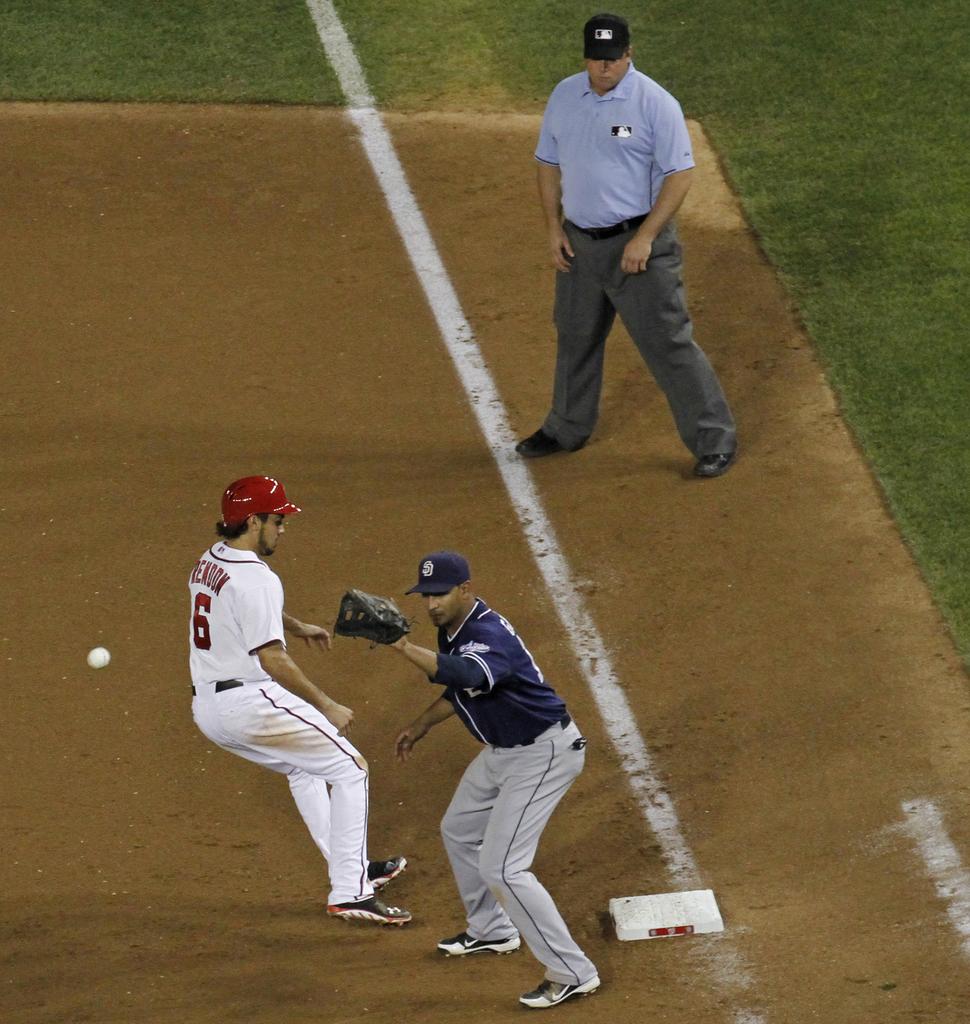What is the number of the player running the bases?
Your answer should be compact. 6. 